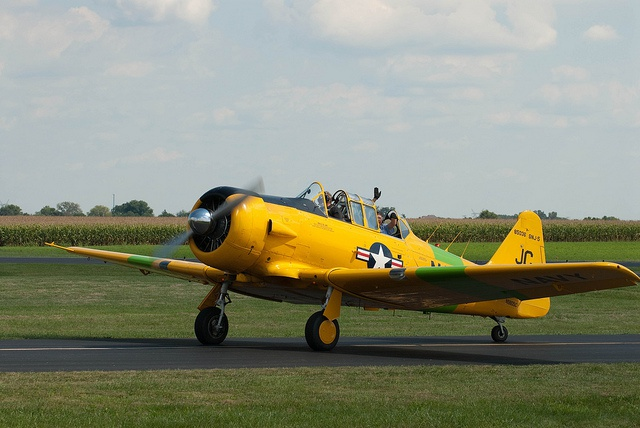Describe the objects in this image and their specific colors. I can see airplane in lightgray, black, orange, gold, and olive tones, people in lightgray, gray, black, maroon, and navy tones, and people in lightgray, black, gray, darkgray, and maroon tones in this image. 